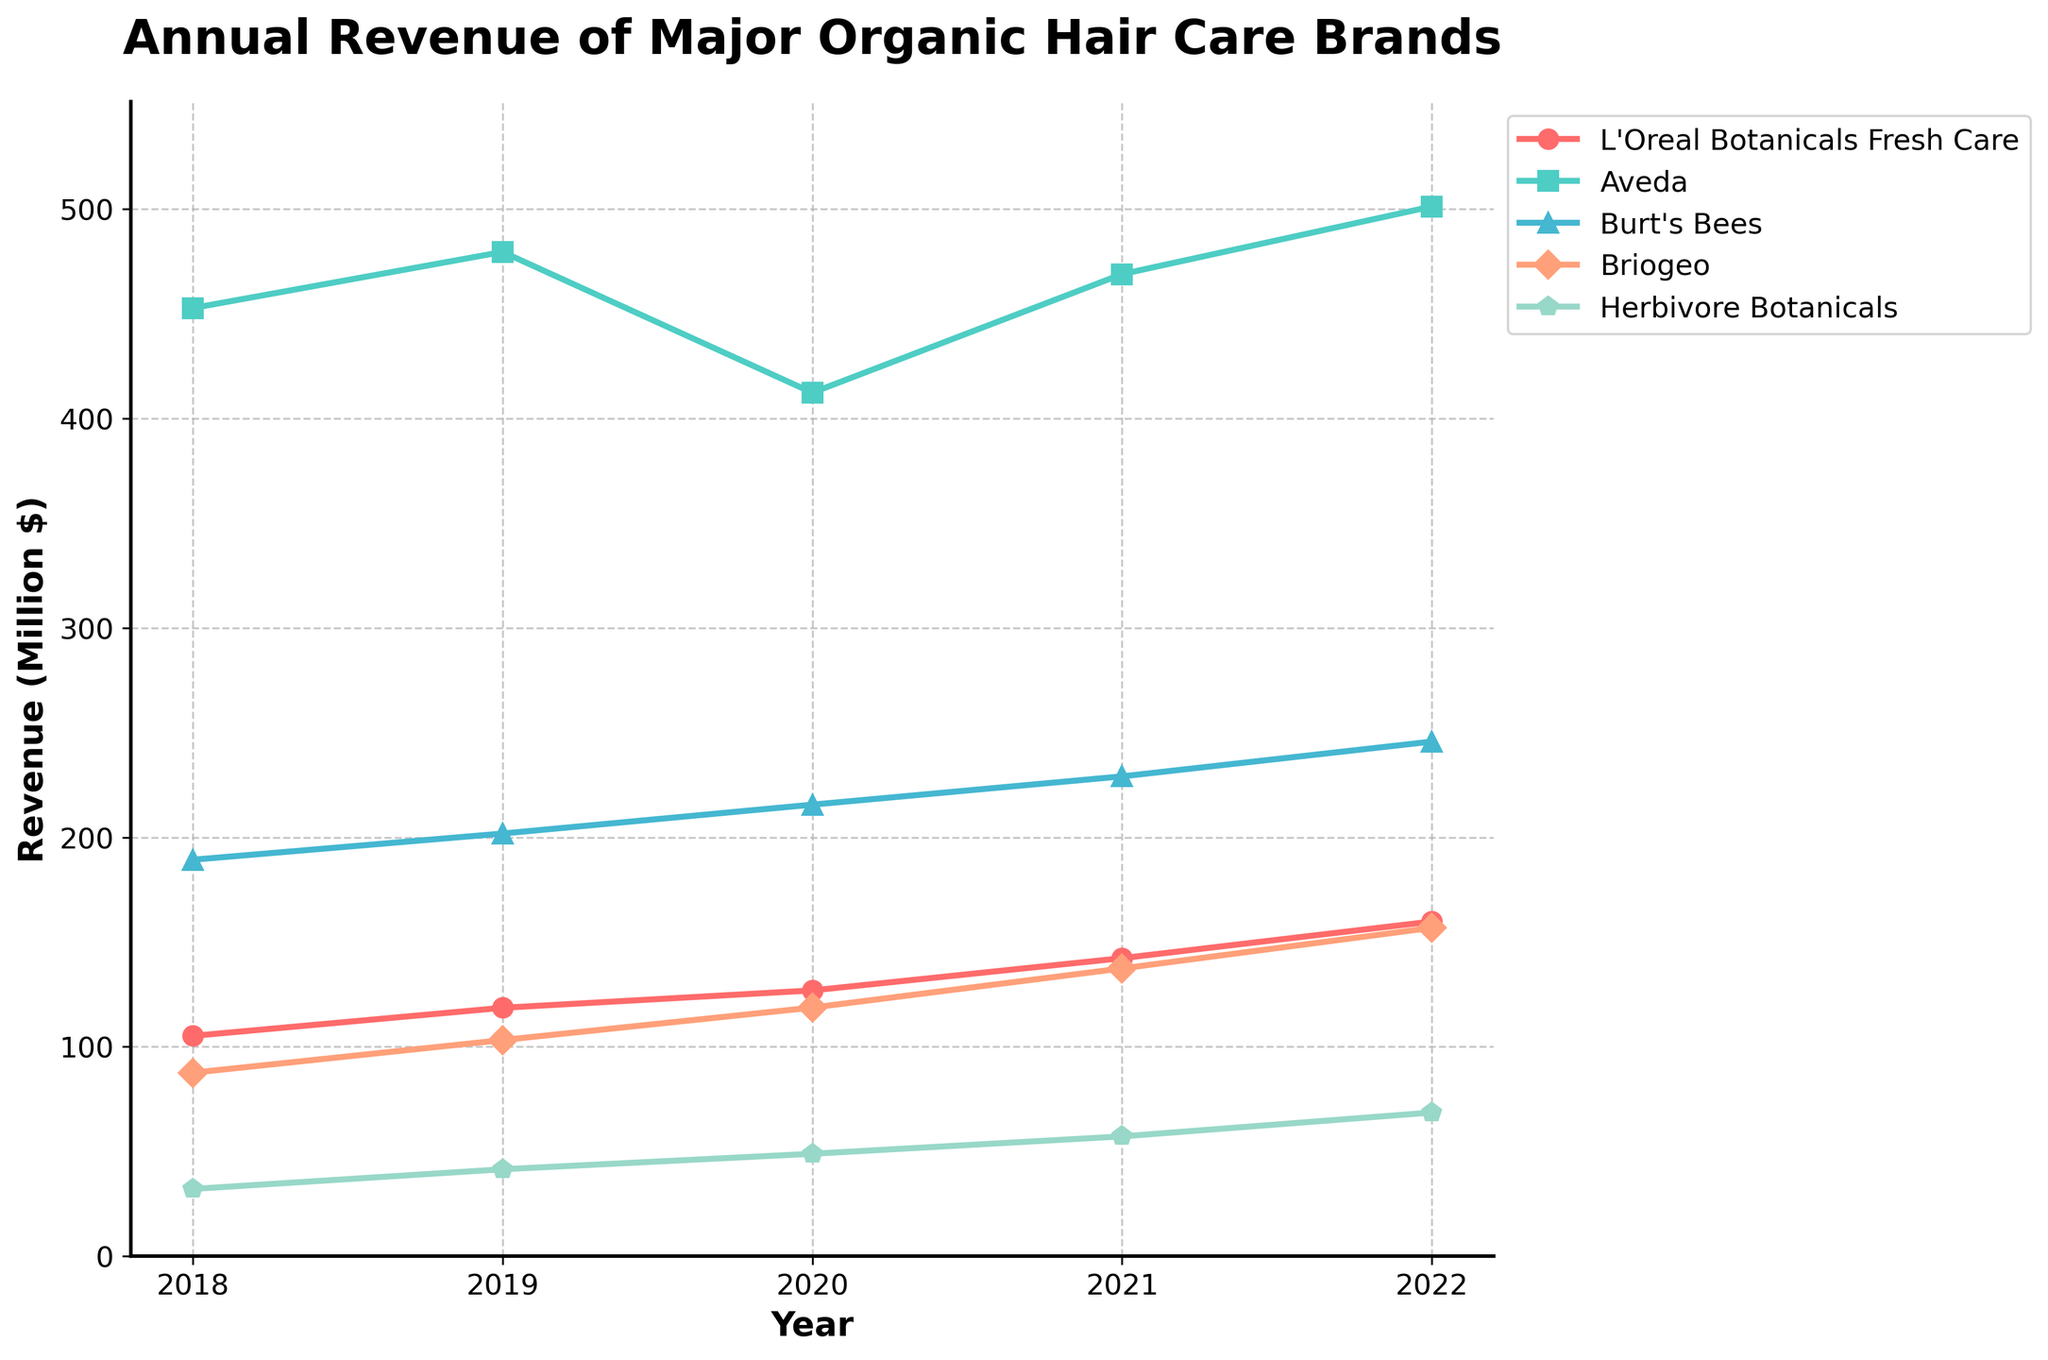Which brand saw the highest increase in revenue from 2018 to 2022? To find the brand with the highest increase, we need to subtract the 2018 revenue from the 2022 revenue for each brand. The calculations are: L'Oreal Botanicals Fresh Care: 159.8 - 105.2 = 54.6, Aveda: 501.2 - 452.7 = 48.5, Burt's Bees: 245.7 - 189.3 = 56.4, Briogeo: 156.8 - 87.6 = 69.2, Herbivore Botanicals: 68.6 - 32.1 = 36.5. The highest increase is for Briogeo with 69.2.
Answer: Briogeo Which brand had the lowest revenue in 2020? We compare the 2020 revenue of all brands: L'Oreal Botanicals Fresh Care: 126.9, Aveda: 412.3, Burt's Bees: 215.6, Briogeo: 118.7, Herbivore Botanicals: 48.9. Herbivore Botanicals has the lowest revenue.
Answer: Herbivore Botanicals What's the average annual revenue of Burt's Bees over the years 2018 to 2022? Add Burt's Bees revenue from 2018, 2019, 2020, 2021, and 2022, then divide by the number of years. This is (189.3 + 201.8 + 215.6 + 229.1 + 245.7) / 5 = 1081.5 / 5 = 216.3.
Answer: 216.3 Which brand experienced a revenue dip in any year? We need to look at each year-to-year comparison for any dip. Aveda: 2019-2018 = 26.8 (increase), 2020-2019 = -67.2 (decrease), 2021-2020 = 56.6 (increase), 2022-2021 = 32.3 (increase). No other brands have a decrease in any year.
Answer: Aveda By how much did Briogeo’s revenue grow from 2018 to 2021? Calculate the difference between 2021 and 2018 for Briogeo: 137.4 - 87.6 = 49.8.
Answer: 49.8 What was the total revenue of L'Oreal Botanicals Fresh Care over the five years? Add the annual revenue from 2018 to 2022 for L'Oreal Botanicals Fresh Care: 105.2 + 118.6 + 126.9 + 142.3 + 159.8 = 652.8.
Answer: 652.8 